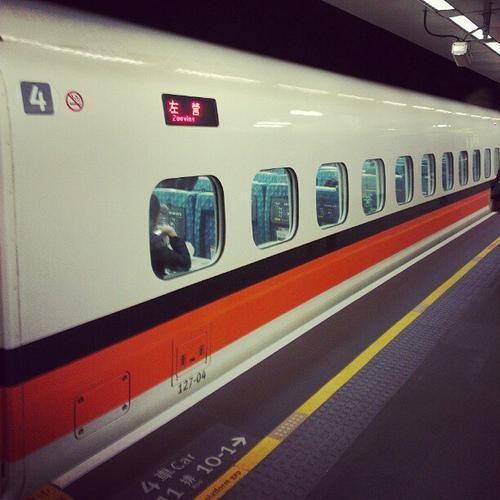How many surveillance cameras can be seen?
Give a very brief answer. 1. 